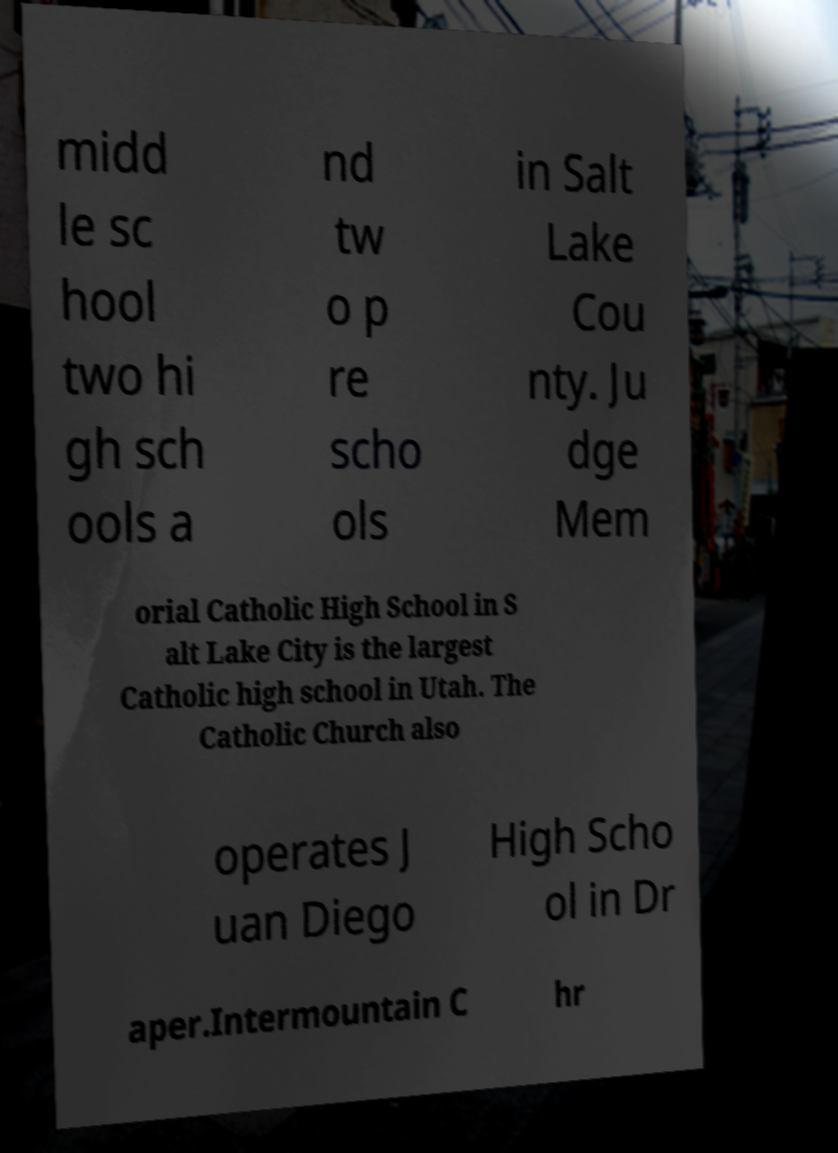I need the written content from this picture converted into text. Can you do that? midd le sc hool two hi gh sch ools a nd tw o p re scho ols in Salt Lake Cou nty. Ju dge Mem orial Catholic High School in S alt Lake City is the largest Catholic high school in Utah. The Catholic Church also operates J uan Diego High Scho ol in Dr aper.Intermountain C hr 